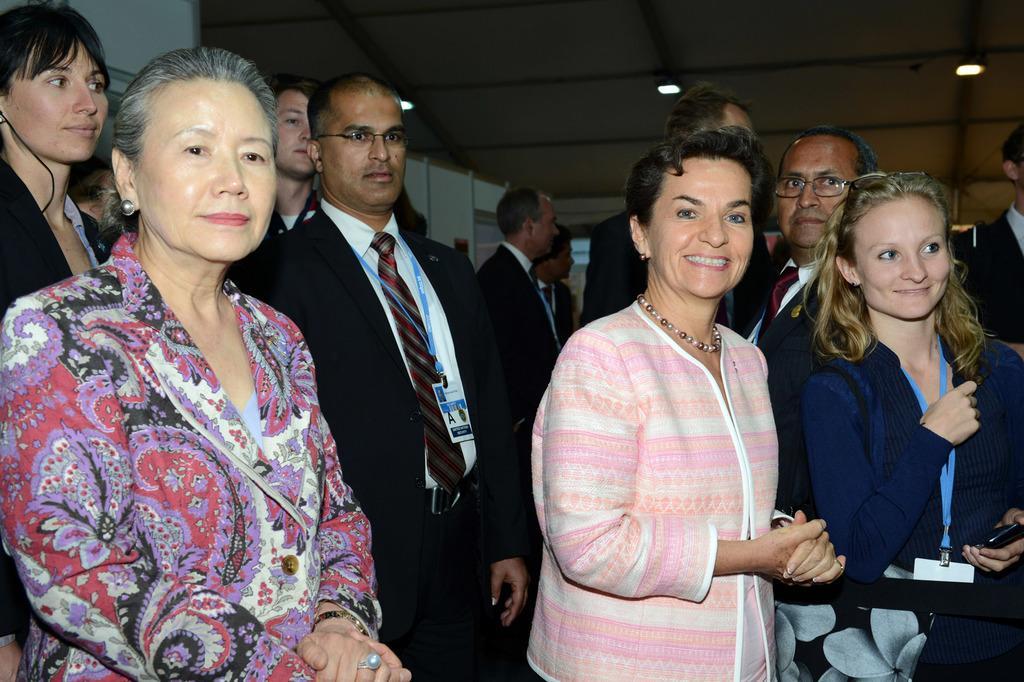Please provide a concise description of this image. In this picture I can see number of people and I see the woman in the front are smiling. On the top of this picture I see the ceiling on which there are lights. I can also see that few men are wearing formal dress. 